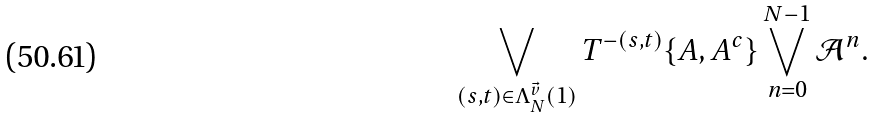Convert formula to latex. <formula><loc_0><loc_0><loc_500><loc_500>\bigvee _ { ( s , t ) \in \Lambda _ { N } ^ { \vec { v } } ( 1 ) } T ^ { - ( s , t ) } \{ A , A ^ { c } \} \bigvee _ { n = 0 } ^ { N - 1 } \mathcal { A } ^ { n } .</formula> 